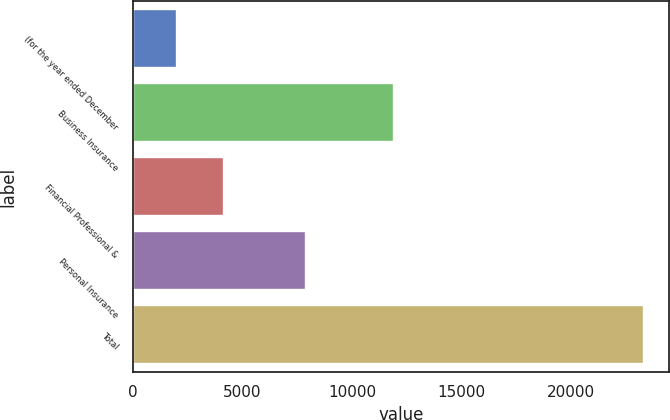<chart> <loc_0><loc_0><loc_500><loc_500><bar_chart><fcel>(for the year ended December<fcel>Business Insurance<fcel>Financial Professional &<fcel>Personal Insurance<fcel>Total<nl><fcel>2010<fcel>11891<fcel>4139.2<fcel>7877<fcel>23302<nl></chart> 